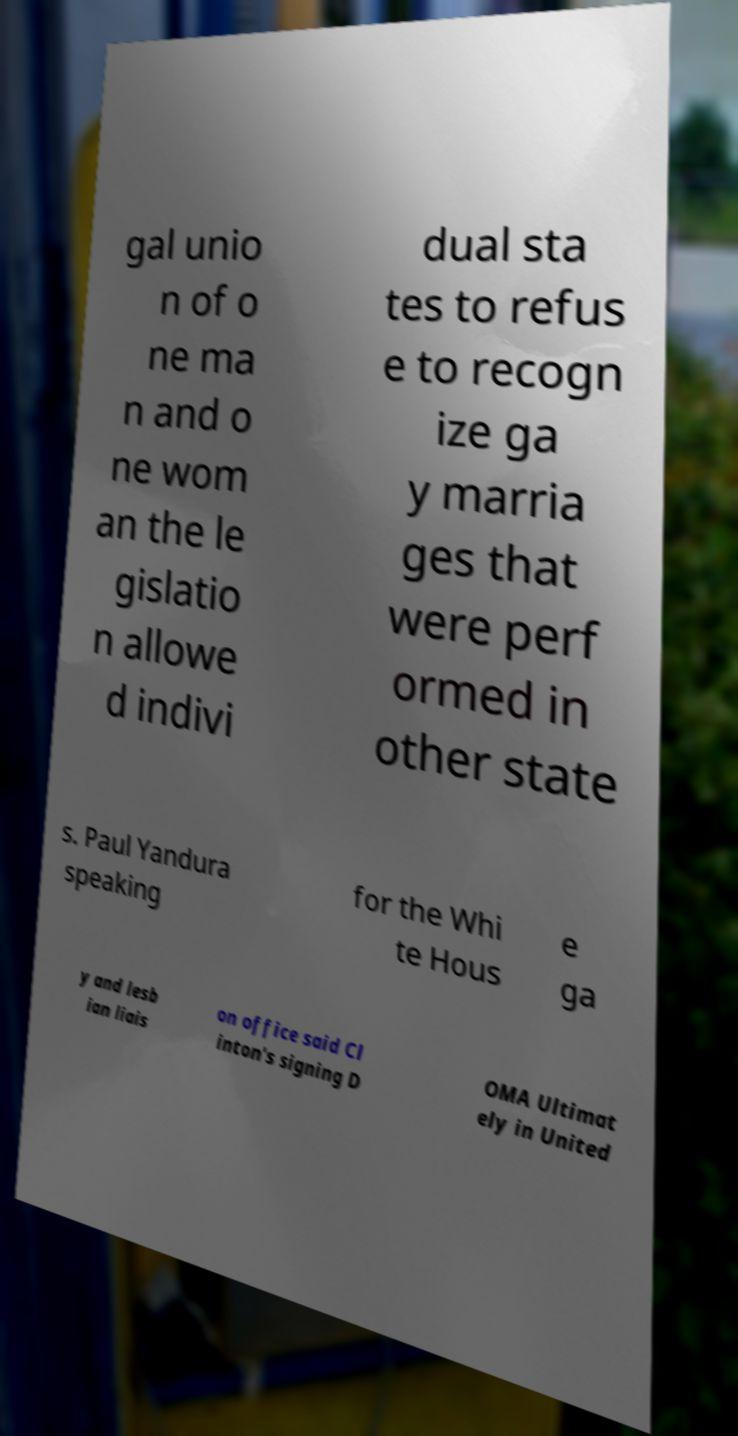For documentation purposes, I need the text within this image transcribed. Could you provide that? gal unio n of o ne ma n and o ne wom an the le gislatio n allowe d indivi dual sta tes to refus e to recogn ize ga y marria ges that were perf ormed in other state s. Paul Yandura speaking for the Whi te Hous e ga y and lesb ian liais on office said Cl inton's signing D OMA Ultimat ely in United 